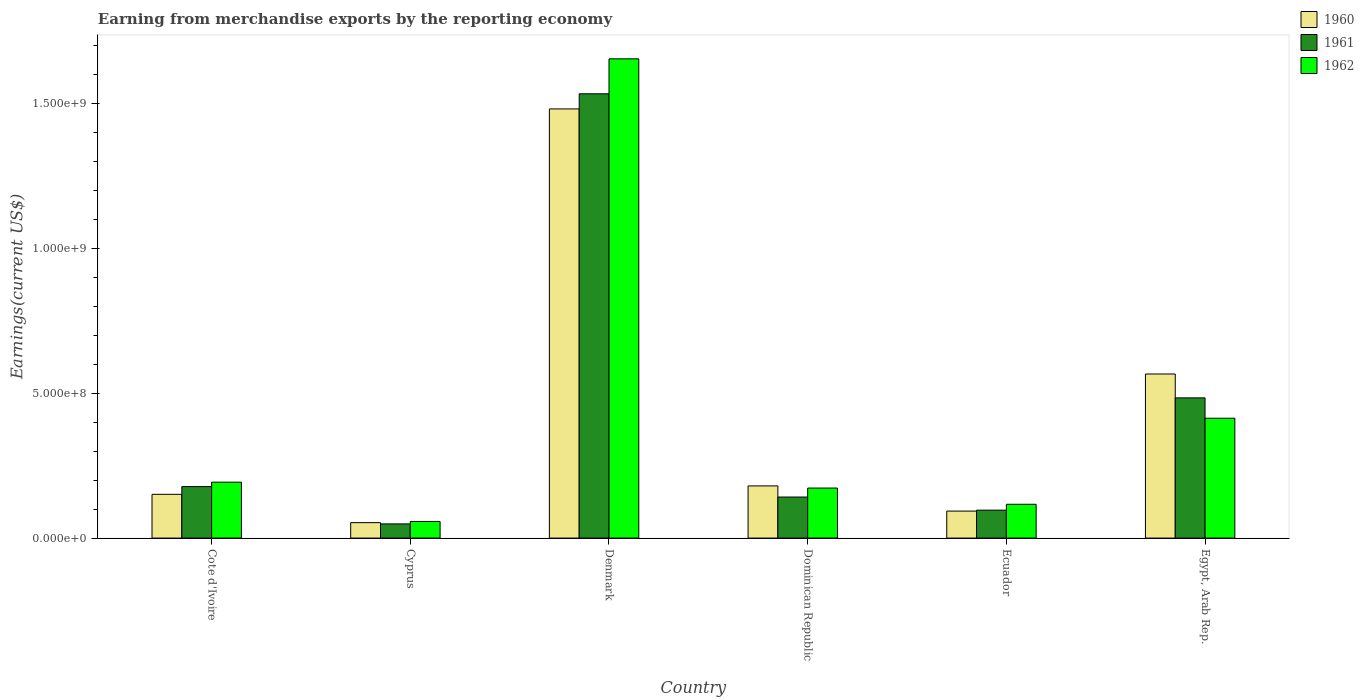Are the number of bars per tick equal to the number of legend labels?
Your response must be concise. Yes. What is the label of the 6th group of bars from the left?
Make the answer very short. Egypt, Arab Rep. In how many cases, is the number of bars for a given country not equal to the number of legend labels?
Provide a short and direct response. 0. What is the amount earned from merchandise exports in 1960 in Ecuador?
Ensure brevity in your answer.  9.33e+07. Across all countries, what is the maximum amount earned from merchandise exports in 1961?
Keep it short and to the point. 1.53e+09. Across all countries, what is the minimum amount earned from merchandise exports in 1962?
Your answer should be compact. 5.75e+07. In which country was the amount earned from merchandise exports in 1961 maximum?
Your response must be concise. Denmark. In which country was the amount earned from merchandise exports in 1960 minimum?
Make the answer very short. Cyprus. What is the total amount earned from merchandise exports in 1962 in the graph?
Your answer should be compact. 2.61e+09. What is the difference between the amount earned from merchandise exports in 1961 in Cyprus and that in Egypt, Arab Rep.?
Your answer should be very brief. -4.35e+08. What is the difference between the amount earned from merchandise exports in 1962 in Cyprus and the amount earned from merchandise exports in 1961 in Dominican Republic?
Keep it short and to the point. -8.43e+07. What is the average amount earned from merchandise exports in 1961 per country?
Your answer should be compact. 4.14e+08. What is the difference between the amount earned from merchandise exports of/in 1962 and amount earned from merchandise exports of/in 1961 in Cote d'Ivoire?
Ensure brevity in your answer.  1.52e+07. What is the ratio of the amount earned from merchandise exports in 1962 in Cote d'Ivoire to that in Cyprus?
Offer a very short reply. 3.36. What is the difference between the highest and the second highest amount earned from merchandise exports in 1960?
Provide a short and direct response. 1.30e+09. What is the difference between the highest and the lowest amount earned from merchandise exports in 1962?
Your response must be concise. 1.60e+09. In how many countries, is the amount earned from merchandise exports in 1961 greater than the average amount earned from merchandise exports in 1961 taken over all countries?
Provide a succinct answer. 2. What does the 2nd bar from the left in Egypt, Arab Rep. represents?
Ensure brevity in your answer.  1961. What does the 1st bar from the right in Cyprus represents?
Make the answer very short. 1962. Are all the bars in the graph horizontal?
Keep it short and to the point. No. Does the graph contain grids?
Ensure brevity in your answer.  No. Where does the legend appear in the graph?
Your answer should be compact. Top right. What is the title of the graph?
Make the answer very short. Earning from merchandise exports by the reporting economy. What is the label or title of the X-axis?
Your response must be concise. Country. What is the label or title of the Y-axis?
Make the answer very short. Earnings(current US$). What is the Earnings(current US$) in 1960 in Cote d'Ivoire?
Provide a succinct answer. 1.51e+08. What is the Earnings(current US$) in 1961 in Cote d'Ivoire?
Offer a very short reply. 1.78e+08. What is the Earnings(current US$) of 1962 in Cote d'Ivoire?
Your answer should be compact. 1.93e+08. What is the Earnings(current US$) in 1960 in Cyprus?
Provide a succinct answer. 5.34e+07. What is the Earnings(current US$) in 1961 in Cyprus?
Provide a short and direct response. 4.90e+07. What is the Earnings(current US$) of 1962 in Cyprus?
Ensure brevity in your answer.  5.75e+07. What is the Earnings(current US$) in 1960 in Denmark?
Make the answer very short. 1.48e+09. What is the Earnings(current US$) in 1961 in Denmark?
Keep it short and to the point. 1.53e+09. What is the Earnings(current US$) in 1962 in Denmark?
Your answer should be compact. 1.66e+09. What is the Earnings(current US$) in 1960 in Dominican Republic?
Provide a succinct answer. 1.80e+08. What is the Earnings(current US$) in 1961 in Dominican Republic?
Your response must be concise. 1.42e+08. What is the Earnings(current US$) of 1962 in Dominican Republic?
Give a very brief answer. 1.73e+08. What is the Earnings(current US$) in 1960 in Ecuador?
Give a very brief answer. 9.33e+07. What is the Earnings(current US$) of 1961 in Ecuador?
Provide a succinct answer. 9.65e+07. What is the Earnings(current US$) of 1962 in Ecuador?
Provide a succinct answer. 1.17e+08. What is the Earnings(current US$) of 1960 in Egypt, Arab Rep.?
Offer a very short reply. 5.67e+08. What is the Earnings(current US$) in 1961 in Egypt, Arab Rep.?
Provide a short and direct response. 4.84e+08. What is the Earnings(current US$) of 1962 in Egypt, Arab Rep.?
Ensure brevity in your answer.  4.14e+08. Across all countries, what is the maximum Earnings(current US$) of 1960?
Keep it short and to the point. 1.48e+09. Across all countries, what is the maximum Earnings(current US$) of 1961?
Ensure brevity in your answer.  1.53e+09. Across all countries, what is the maximum Earnings(current US$) in 1962?
Offer a terse response. 1.66e+09. Across all countries, what is the minimum Earnings(current US$) in 1960?
Offer a very short reply. 5.34e+07. Across all countries, what is the minimum Earnings(current US$) of 1961?
Your answer should be compact. 4.90e+07. Across all countries, what is the minimum Earnings(current US$) in 1962?
Offer a terse response. 5.75e+07. What is the total Earnings(current US$) in 1960 in the graph?
Make the answer very short. 2.53e+09. What is the total Earnings(current US$) of 1961 in the graph?
Ensure brevity in your answer.  2.48e+09. What is the total Earnings(current US$) in 1962 in the graph?
Give a very brief answer. 2.61e+09. What is the difference between the Earnings(current US$) in 1960 in Cote d'Ivoire and that in Cyprus?
Provide a succinct answer. 9.78e+07. What is the difference between the Earnings(current US$) of 1961 in Cote d'Ivoire and that in Cyprus?
Provide a short and direct response. 1.29e+08. What is the difference between the Earnings(current US$) of 1962 in Cote d'Ivoire and that in Cyprus?
Your answer should be very brief. 1.36e+08. What is the difference between the Earnings(current US$) in 1960 in Cote d'Ivoire and that in Denmark?
Ensure brevity in your answer.  -1.33e+09. What is the difference between the Earnings(current US$) of 1961 in Cote d'Ivoire and that in Denmark?
Your response must be concise. -1.36e+09. What is the difference between the Earnings(current US$) of 1962 in Cote d'Ivoire and that in Denmark?
Your response must be concise. -1.46e+09. What is the difference between the Earnings(current US$) in 1960 in Cote d'Ivoire and that in Dominican Republic?
Give a very brief answer. -2.90e+07. What is the difference between the Earnings(current US$) of 1961 in Cote d'Ivoire and that in Dominican Republic?
Keep it short and to the point. 3.61e+07. What is the difference between the Earnings(current US$) in 1962 in Cote d'Ivoire and that in Dominican Republic?
Your answer should be very brief. 2.03e+07. What is the difference between the Earnings(current US$) in 1960 in Cote d'Ivoire and that in Ecuador?
Provide a succinct answer. 5.79e+07. What is the difference between the Earnings(current US$) of 1961 in Cote d'Ivoire and that in Ecuador?
Keep it short and to the point. 8.14e+07. What is the difference between the Earnings(current US$) of 1962 in Cote d'Ivoire and that in Ecuador?
Offer a very short reply. 7.63e+07. What is the difference between the Earnings(current US$) in 1960 in Cote d'Ivoire and that in Egypt, Arab Rep.?
Give a very brief answer. -4.16e+08. What is the difference between the Earnings(current US$) of 1961 in Cote d'Ivoire and that in Egypt, Arab Rep.?
Offer a very short reply. -3.06e+08. What is the difference between the Earnings(current US$) of 1962 in Cote d'Ivoire and that in Egypt, Arab Rep.?
Offer a terse response. -2.21e+08. What is the difference between the Earnings(current US$) of 1960 in Cyprus and that in Denmark?
Offer a very short reply. -1.43e+09. What is the difference between the Earnings(current US$) of 1961 in Cyprus and that in Denmark?
Make the answer very short. -1.49e+09. What is the difference between the Earnings(current US$) in 1962 in Cyprus and that in Denmark?
Your answer should be compact. -1.60e+09. What is the difference between the Earnings(current US$) in 1960 in Cyprus and that in Dominican Republic?
Your answer should be very brief. -1.27e+08. What is the difference between the Earnings(current US$) of 1961 in Cyprus and that in Dominican Republic?
Your answer should be compact. -9.28e+07. What is the difference between the Earnings(current US$) of 1962 in Cyprus and that in Dominican Republic?
Offer a very short reply. -1.15e+08. What is the difference between the Earnings(current US$) in 1960 in Cyprus and that in Ecuador?
Your answer should be compact. -3.99e+07. What is the difference between the Earnings(current US$) in 1961 in Cyprus and that in Ecuador?
Provide a succinct answer. -4.75e+07. What is the difference between the Earnings(current US$) of 1962 in Cyprus and that in Ecuador?
Ensure brevity in your answer.  -5.93e+07. What is the difference between the Earnings(current US$) in 1960 in Cyprus and that in Egypt, Arab Rep.?
Offer a terse response. -5.13e+08. What is the difference between the Earnings(current US$) of 1961 in Cyprus and that in Egypt, Arab Rep.?
Give a very brief answer. -4.35e+08. What is the difference between the Earnings(current US$) of 1962 in Cyprus and that in Egypt, Arab Rep.?
Provide a succinct answer. -3.56e+08. What is the difference between the Earnings(current US$) of 1960 in Denmark and that in Dominican Republic?
Give a very brief answer. 1.30e+09. What is the difference between the Earnings(current US$) of 1961 in Denmark and that in Dominican Republic?
Your response must be concise. 1.39e+09. What is the difference between the Earnings(current US$) in 1962 in Denmark and that in Dominican Republic?
Give a very brief answer. 1.48e+09. What is the difference between the Earnings(current US$) in 1960 in Denmark and that in Ecuador?
Your response must be concise. 1.39e+09. What is the difference between the Earnings(current US$) in 1961 in Denmark and that in Ecuador?
Your answer should be very brief. 1.44e+09. What is the difference between the Earnings(current US$) in 1962 in Denmark and that in Ecuador?
Provide a short and direct response. 1.54e+09. What is the difference between the Earnings(current US$) in 1960 in Denmark and that in Egypt, Arab Rep.?
Your response must be concise. 9.16e+08. What is the difference between the Earnings(current US$) of 1961 in Denmark and that in Egypt, Arab Rep.?
Offer a terse response. 1.05e+09. What is the difference between the Earnings(current US$) in 1962 in Denmark and that in Egypt, Arab Rep.?
Keep it short and to the point. 1.24e+09. What is the difference between the Earnings(current US$) in 1960 in Dominican Republic and that in Ecuador?
Offer a very short reply. 8.69e+07. What is the difference between the Earnings(current US$) of 1961 in Dominican Republic and that in Ecuador?
Your response must be concise. 4.53e+07. What is the difference between the Earnings(current US$) of 1962 in Dominican Republic and that in Ecuador?
Your answer should be very brief. 5.60e+07. What is the difference between the Earnings(current US$) in 1960 in Dominican Republic and that in Egypt, Arab Rep.?
Offer a terse response. -3.87e+08. What is the difference between the Earnings(current US$) of 1961 in Dominican Republic and that in Egypt, Arab Rep.?
Provide a short and direct response. -3.42e+08. What is the difference between the Earnings(current US$) in 1962 in Dominican Republic and that in Egypt, Arab Rep.?
Give a very brief answer. -2.41e+08. What is the difference between the Earnings(current US$) of 1960 in Ecuador and that in Egypt, Arab Rep.?
Provide a succinct answer. -4.74e+08. What is the difference between the Earnings(current US$) of 1961 in Ecuador and that in Egypt, Arab Rep.?
Make the answer very short. -3.88e+08. What is the difference between the Earnings(current US$) in 1962 in Ecuador and that in Egypt, Arab Rep.?
Keep it short and to the point. -2.97e+08. What is the difference between the Earnings(current US$) of 1960 in Cote d'Ivoire and the Earnings(current US$) of 1961 in Cyprus?
Your answer should be very brief. 1.02e+08. What is the difference between the Earnings(current US$) of 1960 in Cote d'Ivoire and the Earnings(current US$) of 1962 in Cyprus?
Provide a succinct answer. 9.37e+07. What is the difference between the Earnings(current US$) of 1961 in Cote d'Ivoire and the Earnings(current US$) of 1962 in Cyprus?
Offer a very short reply. 1.20e+08. What is the difference between the Earnings(current US$) in 1960 in Cote d'Ivoire and the Earnings(current US$) in 1961 in Denmark?
Make the answer very short. -1.38e+09. What is the difference between the Earnings(current US$) in 1960 in Cote d'Ivoire and the Earnings(current US$) in 1962 in Denmark?
Ensure brevity in your answer.  -1.50e+09. What is the difference between the Earnings(current US$) in 1961 in Cote d'Ivoire and the Earnings(current US$) in 1962 in Denmark?
Your answer should be compact. -1.48e+09. What is the difference between the Earnings(current US$) in 1960 in Cote d'Ivoire and the Earnings(current US$) in 1961 in Dominican Republic?
Keep it short and to the point. 9.39e+06. What is the difference between the Earnings(current US$) in 1960 in Cote d'Ivoire and the Earnings(current US$) in 1962 in Dominican Republic?
Provide a short and direct response. -2.16e+07. What is the difference between the Earnings(current US$) in 1961 in Cote d'Ivoire and the Earnings(current US$) in 1962 in Dominican Republic?
Offer a terse response. 5.08e+06. What is the difference between the Earnings(current US$) of 1960 in Cote d'Ivoire and the Earnings(current US$) of 1961 in Ecuador?
Your response must be concise. 5.47e+07. What is the difference between the Earnings(current US$) of 1960 in Cote d'Ivoire and the Earnings(current US$) of 1962 in Ecuador?
Offer a very short reply. 3.44e+07. What is the difference between the Earnings(current US$) of 1961 in Cote d'Ivoire and the Earnings(current US$) of 1962 in Ecuador?
Your answer should be compact. 6.11e+07. What is the difference between the Earnings(current US$) of 1960 in Cote d'Ivoire and the Earnings(current US$) of 1961 in Egypt, Arab Rep.?
Offer a very short reply. -3.33e+08. What is the difference between the Earnings(current US$) in 1960 in Cote d'Ivoire and the Earnings(current US$) in 1962 in Egypt, Arab Rep.?
Ensure brevity in your answer.  -2.63e+08. What is the difference between the Earnings(current US$) of 1961 in Cote d'Ivoire and the Earnings(current US$) of 1962 in Egypt, Arab Rep.?
Offer a very short reply. -2.36e+08. What is the difference between the Earnings(current US$) of 1960 in Cyprus and the Earnings(current US$) of 1961 in Denmark?
Provide a short and direct response. -1.48e+09. What is the difference between the Earnings(current US$) of 1960 in Cyprus and the Earnings(current US$) of 1962 in Denmark?
Give a very brief answer. -1.60e+09. What is the difference between the Earnings(current US$) of 1961 in Cyprus and the Earnings(current US$) of 1962 in Denmark?
Your response must be concise. -1.61e+09. What is the difference between the Earnings(current US$) in 1960 in Cyprus and the Earnings(current US$) in 1961 in Dominican Republic?
Provide a short and direct response. -8.84e+07. What is the difference between the Earnings(current US$) of 1960 in Cyprus and the Earnings(current US$) of 1962 in Dominican Republic?
Provide a succinct answer. -1.19e+08. What is the difference between the Earnings(current US$) of 1961 in Cyprus and the Earnings(current US$) of 1962 in Dominican Republic?
Your answer should be very brief. -1.24e+08. What is the difference between the Earnings(current US$) in 1960 in Cyprus and the Earnings(current US$) in 1961 in Ecuador?
Your answer should be very brief. -4.31e+07. What is the difference between the Earnings(current US$) in 1960 in Cyprus and the Earnings(current US$) in 1962 in Ecuador?
Offer a very short reply. -6.34e+07. What is the difference between the Earnings(current US$) of 1961 in Cyprus and the Earnings(current US$) of 1962 in Ecuador?
Give a very brief answer. -6.78e+07. What is the difference between the Earnings(current US$) in 1960 in Cyprus and the Earnings(current US$) in 1961 in Egypt, Arab Rep.?
Offer a terse response. -4.31e+08. What is the difference between the Earnings(current US$) of 1960 in Cyprus and the Earnings(current US$) of 1962 in Egypt, Arab Rep.?
Give a very brief answer. -3.61e+08. What is the difference between the Earnings(current US$) of 1961 in Cyprus and the Earnings(current US$) of 1962 in Egypt, Arab Rep.?
Make the answer very short. -3.65e+08. What is the difference between the Earnings(current US$) of 1960 in Denmark and the Earnings(current US$) of 1961 in Dominican Republic?
Offer a very short reply. 1.34e+09. What is the difference between the Earnings(current US$) of 1960 in Denmark and the Earnings(current US$) of 1962 in Dominican Republic?
Make the answer very short. 1.31e+09. What is the difference between the Earnings(current US$) in 1961 in Denmark and the Earnings(current US$) in 1962 in Dominican Republic?
Give a very brief answer. 1.36e+09. What is the difference between the Earnings(current US$) in 1960 in Denmark and the Earnings(current US$) in 1961 in Ecuador?
Your response must be concise. 1.39e+09. What is the difference between the Earnings(current US$) of 1960 in Denmark and the Earnings(current US$) of 1962 in Ecuador?
Your response must be concise. 1.37e+09. What is the difference between the Earnings(current US$) in 1961 in Denmark and the Earnings(current US$) in 1962 in Ecuador?
Give a very brief answer. 1.42e+09. What is the difference between the Earnings(current US$) in 1960 in Denmark and the Earnings(current US$) in 1961 in Egypt, Arab Rep.?
Give a very brief answer. 9.98e+08. What is the difference between the Earnings(current US$) in 1960 in Denmark and the Earnings(current US$) in 1962 in Egypt, Arab Rep.?
Offer a terse response. 1.07e+09. What is the difference between the Earnings(current US$) of 1961 in Denmark and the Earnings(current US$) of 1962 in Egypt, Arab Rep.?
Make the answer very short. 1.12e+09. What is the difference between the Earnings(current US$) in 1960 in Dominican Republic and the Earnings(current US$) in 1961 in Ecuador?
Your answer should be very brief. 8.37e+07. What is the difference between the Earnings(current US$) of 1960 in Dominican Republic and the Earnings(current US$) of 1962 in Ecuador?
Keep it short and to the point. 6.34e+07. What is the difference between the Earnings(current US$) in 1961 in Dominican Republic and the Earnings(current US$) in 1962 in Ecuador?
Give a very brief answer. 2.50e+07. What is the difference between the Earnings(current US$) of 1960 in Dominican Republic and the Earnings(current US$) of 1961 in Egypt, Arab Rep.?
Your answer should be compact. -3.04e+08. What is the difference between the Earnings(current US$) of 1960 in Dominican Republic and the Earnings(current US$) of 1962 in Egypt, Arab Rep.?
Your response must be concise. -2.34e+08. What is the difference between the Earnings(current US$) of 1961 in Dominican Republic and the Earnings(current US$) of 1962 in Egypt, Arab Rep.?
Offer a very short reply. -2.72e+08. What is the difference between the Earnings(current US$) in 1960 in Ecuador and the Earnings(current US$) in 1961 in Egypt, Arab Rep.?
Provide a succinct answer. -3.91e+08. What is the difference between the Earnings(current US$) in 1960 in Ecuador and the Earnings(current US$) in 1962 in Egypt, Arab Rep.?
Offer a very short reply. -3.21e+08. What is the difference between the Earnings(current US$) in 1961 in Ecuador and the Earnings(current US$) in 1962 in Egypt, Arab Rep.?
Make the answer very short. -3.18e+08. What is the average Earnings(current US$) in 1960 per country?
Your response must be concise. 4.21e+08. What is the average Earnings(current US$) in 1961 per country?
Make the answer very short. 4.14e+08. What is the average Earnings(current US$) of 1962 per country?
Provide a succinct answer. 4.35e+08. What is the difference between the Earnings(current US$) in 1960 and Earnings(current US$) in 1961 in Cote d'Ivoire?
Keep it short and to the point. -2.67e+07. What is the difference between the Earnings(current US$) in 1960 and Earnings(current US$) in 1962 in Cote d'Ivoire?
Ensure brevity in your answer.  -4.19e+07. What is the difference between the Earnings(current US$) of 1961 and Earnings(current US$) of 1962 in Cote d'Ivoire?
Offer a very short reply. -1.52e+07. What is the difference between the Earnings(current US$) in 1960 and Earnings(current US$) in 1961 in Cyprus?
Your answer should be very brief. 4.40e+06. What is the difference between the Earnings(current US$) of 1960 and Earnings(current US$) of 1962 in Cyprus?
Make the answer very short. -4.10e+06. What is the difference between the Earnings(current US$) in 1961 and Earnings(current US$) in 1962 in Cyprus?
Provide a succinct answer. -8.50e+06. What is the difference between the Earnings(current US$) in 1960 and Earnings(current US$) in 1961 in Denmark?
Ensure brevity in your answer.  -5.23e+07. What is the difference between the Earnings(current US$) in 1960 and Earnings(current US$) in 1962 in Denmark?
Your answer should be compact. -1.73e+08. What is the difference between the Earnings(current US$) in 1961 and Earnings(current US$) in 1962 in Denmark?
Keep it short and to the point. -1.21e+08. What is the difference between the Earnings(current US$) in 1960 and Earnings(current US$) in 1961 in Dominican Republic?
Give a very brief answer. 3.84e+07. What is the difference between the Earnings(current US$) in 1960 and Earnings(current US$) in 1962 in Dominican Republic?
Offer a terse response. 7.38e+06. What is the difference between the Earnings(current US$) in 1961 and Earnings(current US$) in 1962 in Dominican Republic?
Your answer should be very brief. -3.10e+07. What is the difference between the Earnings(current US$) in 1960 and Earnings(current US$) in 1961 in Ecuador?
Your answer should be very brief. -3.20e+06. What is the difference between the Earnings(current US$) in 1960 and Earnings(current US$) in 1962 in Ecuador?
Your answer should be compact. -2.35e+07. What is the difference between the Earnings(current US$) in 1961 and Earnings(current US$) in 1962 in Ecuador?
Make the answer very short. -2.03e+07. What is the difference between the Earnings(current US$) of 1960 and Earnings(current US$) of 1961 in Egypt, Arab Rep.?
Keep it short and to the point. 8.25e+07. What is the difference between the Earnings(current US$) of 1960 and Earnings(current US$) of 1962 in Egypt, Arab Rep.?
Give a very brief answer. 1.53e+08. What is the difference between the Earnings(current US$) in 1961 and Earnings(current US$) in 1962 in Egypt, Arab Rep.?
Provide a succinct answer. 7.03e+07. What is the ratio of the Earnings(current US$) in 1960 in Cote d'Ivoire to that in Cyprus?
Your response must be concise. 2.83. What is the ratio of the Earnings(current US$) in 1961 in Cote d'Ivoire to that in Cyprus?
Keep it short and to the point. 3.63. What is the ratio of the Earnings(current US$) in 1962 in Cote d'Ivoire to that in Cyprus?
Ensure brevity in your answer.  3.36. What is the ratio of the Earnings(current US$) in 1960 in Cote d'Ivoire to that in Denmark?
Offer a terse response. 0.1. What is the ratio of the Earnings(current US$) in 1961 in Cote d'Ivoire to that in Denmark?
Offer a very short reply. 0.12. What is the ratio of the Earnings(current US$) in 1962 in Cote d'Ivoire to that in Denmark?
Your response must be concise. 0.12. What is the ratio of the Earnings(current US$) of 1960 in Cote d'Ivoire to that in Dominican Republic?
Make the answer very short. 0.84. What is the ratio of the Earnings(current US$) of 1961 in Cote d'Ivoire to that in Dominican Republic?
Ensure brevity in your answer.  1.25. What is the ratio of the Earnings(current US$) of 1962 in Cote d'Ivoire to that in Dominican Republic?
Provide a succinct answer. 1.12. What is the ratio of the Earnings(current US$) of 1960 in Cote d'Ivoire to that in Ecuador?
Keep it short and to the point. 1.62. What is the ratio of the Earnings(current US$) in 1961 in Cote d'Ivoire to that in Ecuador?
Your answer should be compact. 1.84. What is the ratio of the Earnings(current US$) of 1962 in Cote d'Ivoire to that in Ecuador?
Provide a succinct answer. 1.65. What is the ratio of the Earnings(current US$) in 1960 in Cote d'Ivoire to that in Egypt, Arab Rep.?
Provide a succinct answer. 0.27. What is the ratio of the Earnings(current US$) in 1961 in Cote d'Ivoire to that in Egypt, Arab Rep.?
Provide a succinct answer. 0.37. What is the ratio of the Earnings(current US$) of 1962 in Cote d'Ivoire to that in Egypt, Arab Rep.?
Ensure brevity in your answer.  0.47. What is the ratio of the Earnings(current US$) in 1960 in Cyprus to that in Denmark?
Give a very brief answer. 0.04. What is the ratio of the Earnings(current US$) of 1961 in Cyprus to that in Denmark?
Your response must be concise. 0.03. What is the ratio of the Earnings(current US$) of 1962 in Cyprus to that in Denmark?
Offer a terse response. 0.03. What is the ratio of the Earnings(current US$) in 1960 in Cyprus to that in Dominican Republic?
Provide a succinct answer. 0.3. What is the ratio of the Earnings(current US$) of 1961 in Cyprus to that in Dominican Republic?
Offer a terse response. 0.35. What is the ratio of the Earnings(current US$) in 1962 in Cyprus to that in Dominican Republic?
Provide a short and direct response. 0.33. What is the ratio of the Earnings(current US$) of 1960 in Cyprus to that in Ecuador?
Make the answer very short. 0.57. What is the ratio of the Earnings(current US$) of 1961 in Cyprus to that in Ecuador?
Provide a short and direct response. 0.51. What is the ratio of the Earnings(current US$) of 1962 in Cyprus to that in Ecuador?
Your answer should be compact. 0.49. What is the ratio of the Earnings(current US$) of 1960 in Cyprus to that in Egypt, Arab Rep.?
Offer a terse response. 0.09. What is the ratio of the Earnings(current US$) in 1961 in Cyprus to that in Egypt, Arab Rep.?
Offer a very short reply. 0.1. What is the ratio of the Earnings(current US$) in 1962 in Cyprus to that in Egypt, Arab Rep.?
Make the answer very short. 0.14. What is the ratio of the Earnings(current US$) in 1960 in Denmark to that in Dominican Republic?
Provide a short and direct response. 8.23. What is the ratio of the Earnings(current US$) in 1961 in Denmark to that in Dominican Republic?
Offer a terse response. 10.82. What is the ratio of the Earnings(current US$) of 1962 in Denmark to that in Dominican Republic?
Give a very brief answer. 9.58. What is the ratio of the Earnings(current US$) in 1960 in Denmark to that in Ecuador?
Offer a terse response. 15.89. What is the ratio of the Earnings(current US$) of 1961 in Denmark to that in Ecuador?
Your answer should be compact. 15.9. What is the ratio of the Earnings(current US$) of 1962 in Denmark to that in Ecuador?
Your answer should be compact. 14.17. What is the ratio of the Earnings(current US$) in 1960 in Denmark to that in Egypt, Arab Rep.?
Your answer should be compact. 2.62. What is the ratio of the Earnings(current US$) of 1961 in Denmark to that in Egypt, Arab Rep.?
Your response must be concise. 3.17. What is the ratio of the Earnings(current US$) in 1962 in Denmark to that in Egypt, Arab Rep.?
Make the answer very short. 4. What is the ratio of the Earnings(current US$) in 1960 in Dominican Republic to that in Ecuador?
Provide a succinct answer. 1.93. What is the ratio of the Earnings(current US$) in 1961 in Dominican Republic to that in Ecuador?
Give a very brief answer. 1.47. What is the ratio of the Earnings(current US$) of 1962 in Dominican Republic to that in Ecuador?
Offer a very short reply. 1.48. What is the ratio of the Earnings(current US$) of 1960 in Dominican Republic to that in Egypt, Arab Rep.?
Give a very brief answer. 0.32. What is the ratio of the Earnings(current US$) of 1961 in Dominican Republic to that in Egypt, Arab Rep.?
Your answer should be compact. 0.29. What is the ratio of the Earnings(current US$) in 1962 in Dominican Republic to that in Egypt, Arab Rep.?
Offer a very short reply. 0.42. What is the ratio of the Earnings(current US$) of 1960 in Ecuador to that in Egypt, Arab Rep.?
Offer a terse response. 0.16. What is the ratio of the Earnings(current US$) in 1961 in Ecuador to that in Egypt, Arab Rep.?
Make the answer very short. 0.2. What is the ratio of the Earnings(current US$) of 1962 in Ecuador to that in Egypt, Arab Rep.?
Give a very brief answer. 0.28. What is the difference between the highest and the second highest Earnings(current US$) in 1960?
Keep it short and to the point. 9.16e+08. What is the difference between the highest and the second highest Earnings(current US$) of 1961?
Your response must be concise. 1.05e+09. What is the difference between the highest and the second highest Earnings(current US$) in 1962?
Your answer should be very brief. 1.24e+09. What is the difference between the highest and the lowest Earnings(current US$) of 1960?
Keep it short and to the point. 1.43e+09. What is the difference between the highest and the lowest Earnings(current US$) in 1961?
Your answer should be compact. 1.49e+09. What is the difference between the highest and the lowest Earnings(current US$) of 1962?
Your answer should be compact. 1.60e+09. 